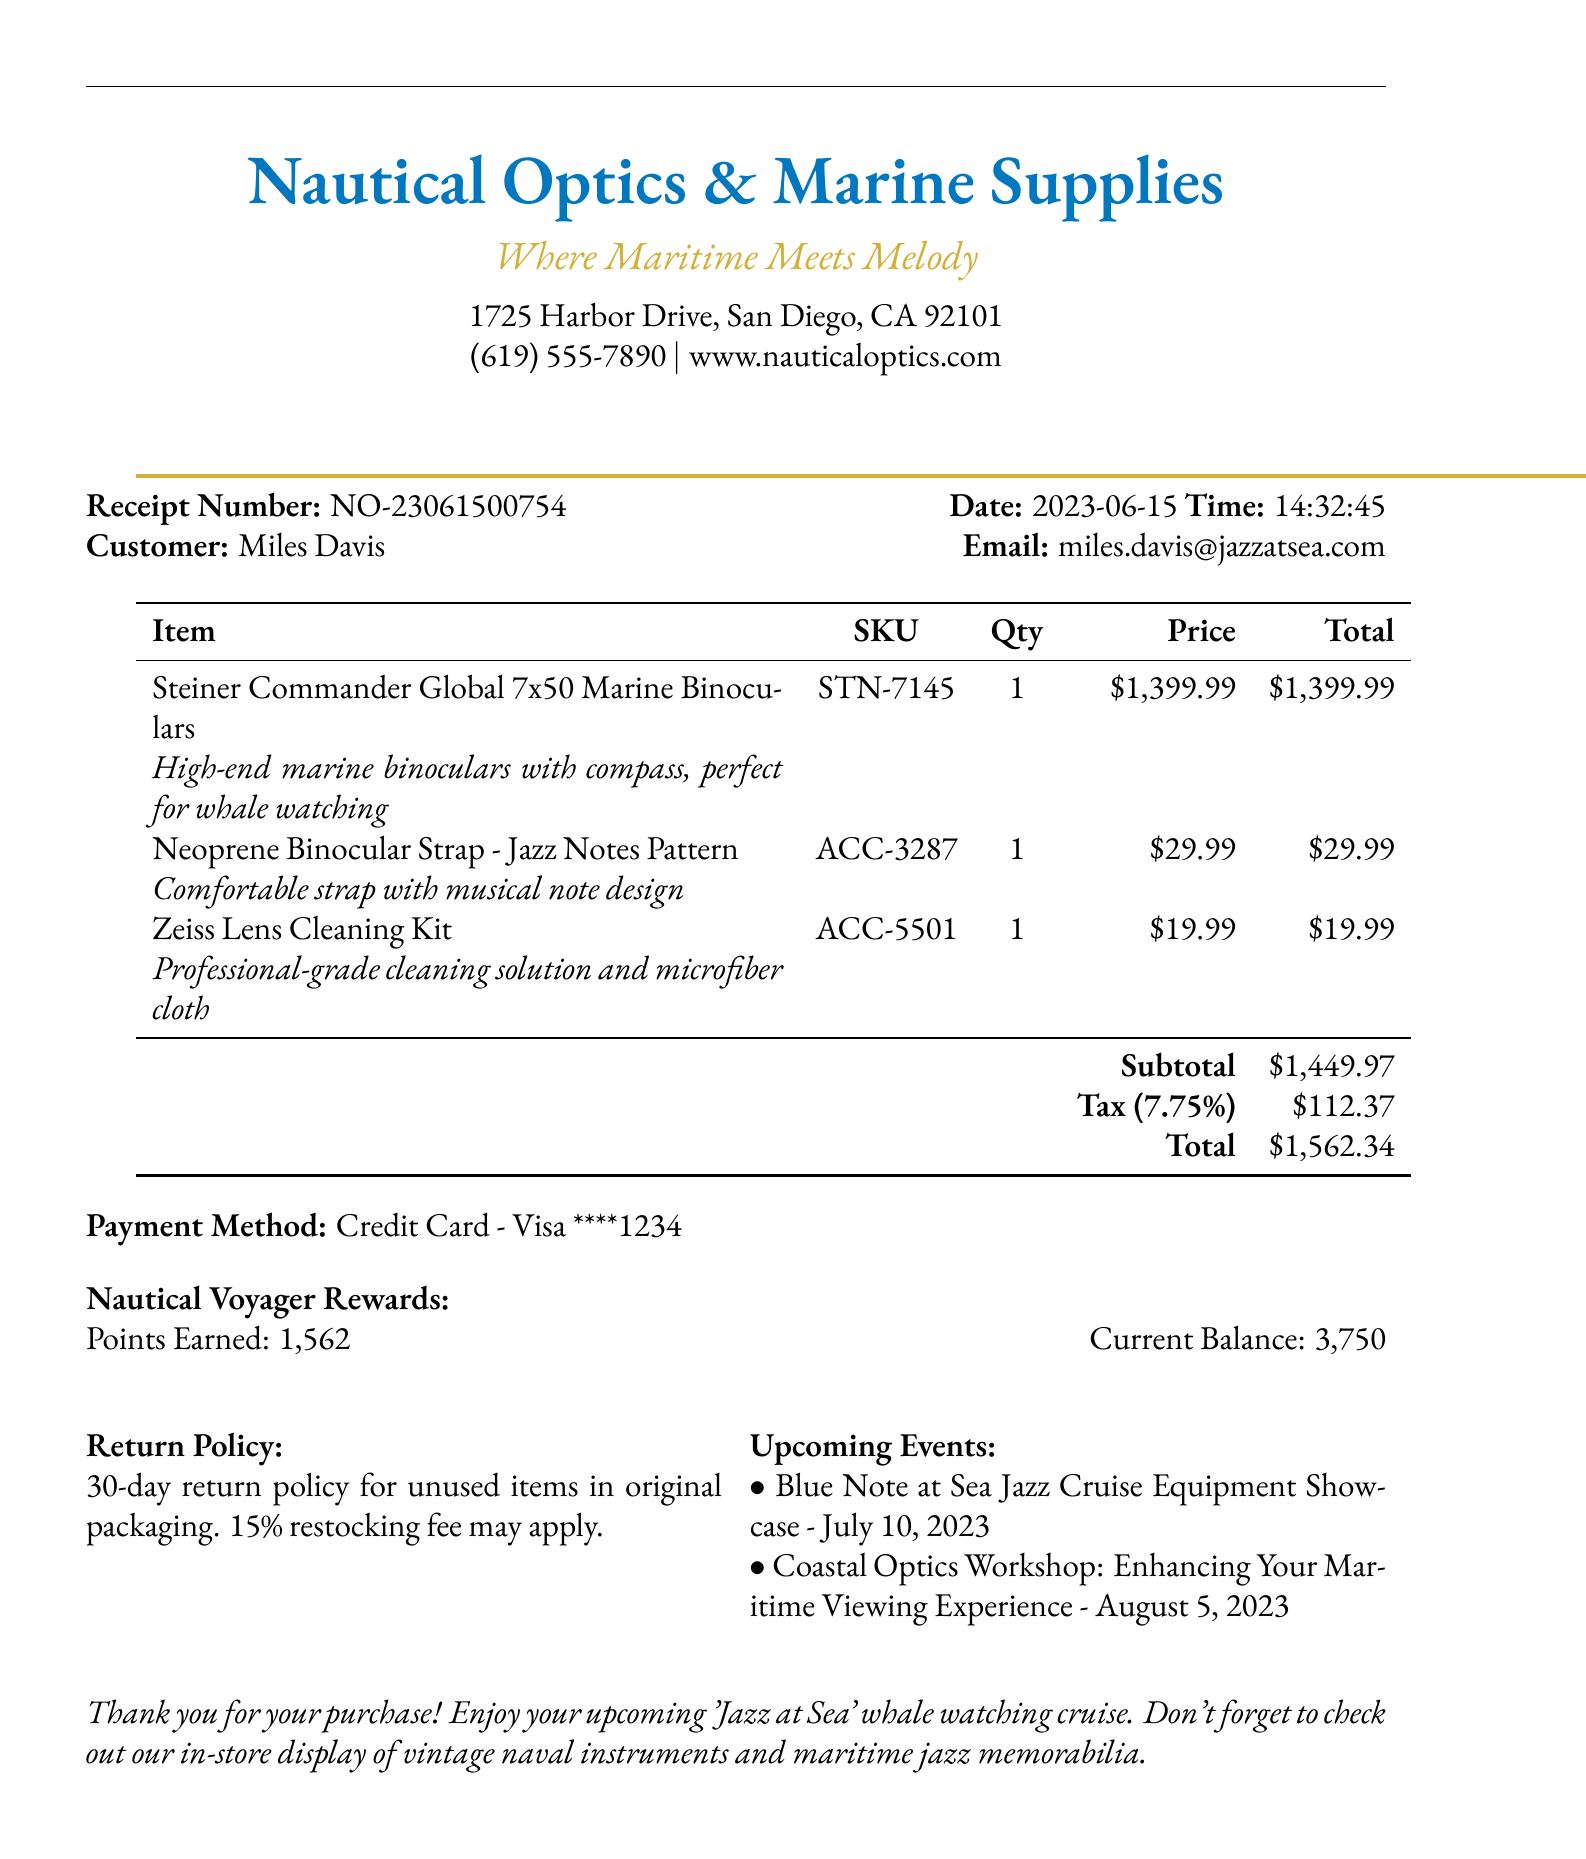What is the store's name? The store's name is presented at the top of the receipt.
Answer: Nautical Optics & Marine Supplies What is the total amount paid? The total amount is calculated at the bottom of the receipt after taxes.
Answer: $1562.34 Who is the customer? The customer's name is provided near the top of the receipt.
Answer: Miles Davis What is the SKU of the binoculars? The SKU is listed next to the binoculars' details in the itemized list.
Answer: STN-7145 How many loyalty points were earned? The points earned are noted in the rewards section of the receipt.
Answer: 1562 What is the tax rate applied? The tax rate is stated explicitly on the receipt before the total amount.
Answer: 7.75% What items were purchased? A list of items is provided in the itemized table on the receipt.
Answer: Steiner Commander Global 7x50 Marine Binoculars, Neoprene Binocular Strap - Jazz Notes Pattern, Zeiss Lens Cleaning Kit What is the return policy? The return policy is described in a dedicated section on the receipt.
Answer: 30-day return policy for unused items in original packaging. 15% restocking fee may apply What is the upcoming event related to jazz? Upcoming events are highlighted towards the bottom of the receipt.
Answer: Blue Note at Sea Jazz Cruise Equipment Showcase - July 10, 2023 